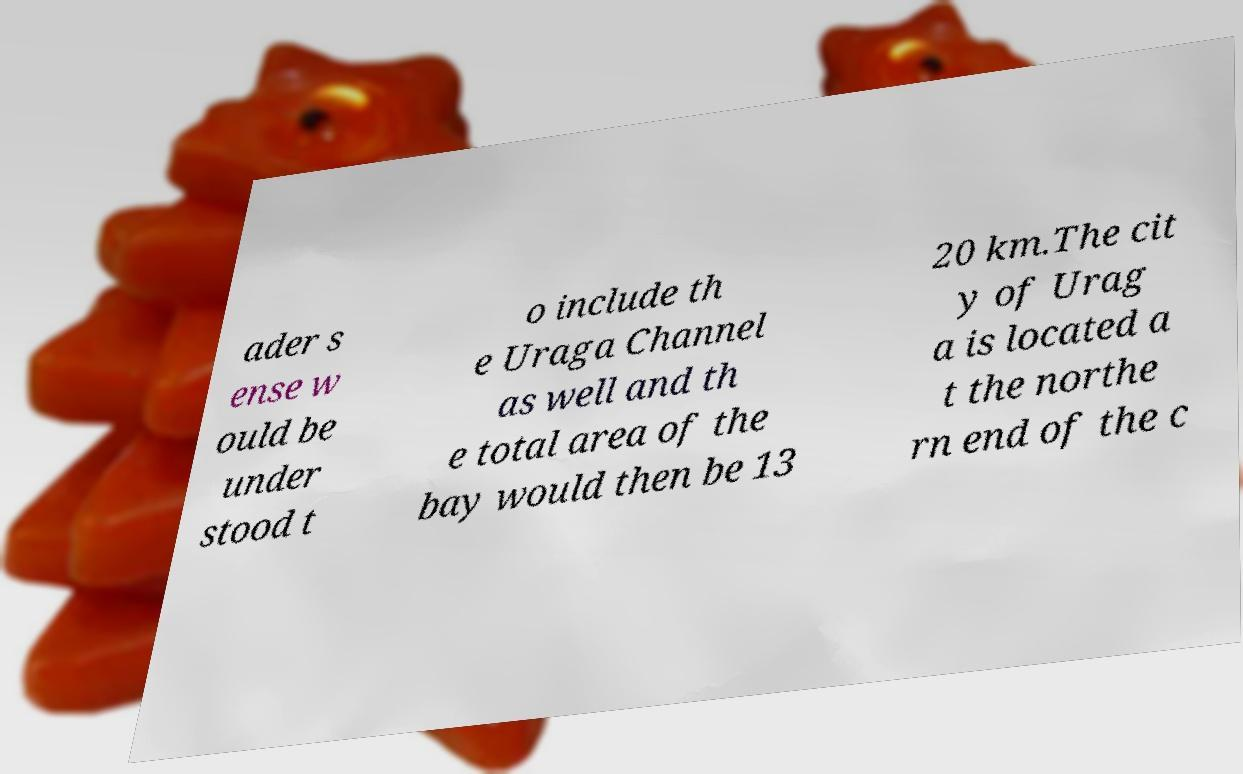There's text embedded in this image that I need extracted. Can you transcribe it verbatim? ader s ense w ould be under stood t o include th e Uraga Channel as well and th e total area of the bay would then be 13 20 km.The cit y of Urag a is located a t the northe rn end of the c 